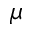<formula> <loc_0><loc_0><loc_500><loc_500>\mu</formula> 